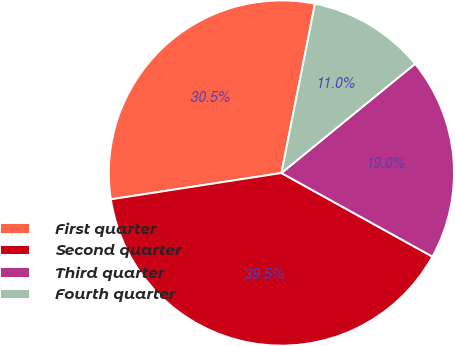Convert chart to OTSL. <chart><loc_0><loc_0><loc_500><loc_500><pie_chart><fcel>First quarter<fcel>Second quarter<fcel>Third quarter<fcel>Fourth quarter<nl><fcel>30.55%<fcel>39.52%<fcel>18.95%<fcel>10.98%<nl></chart> 